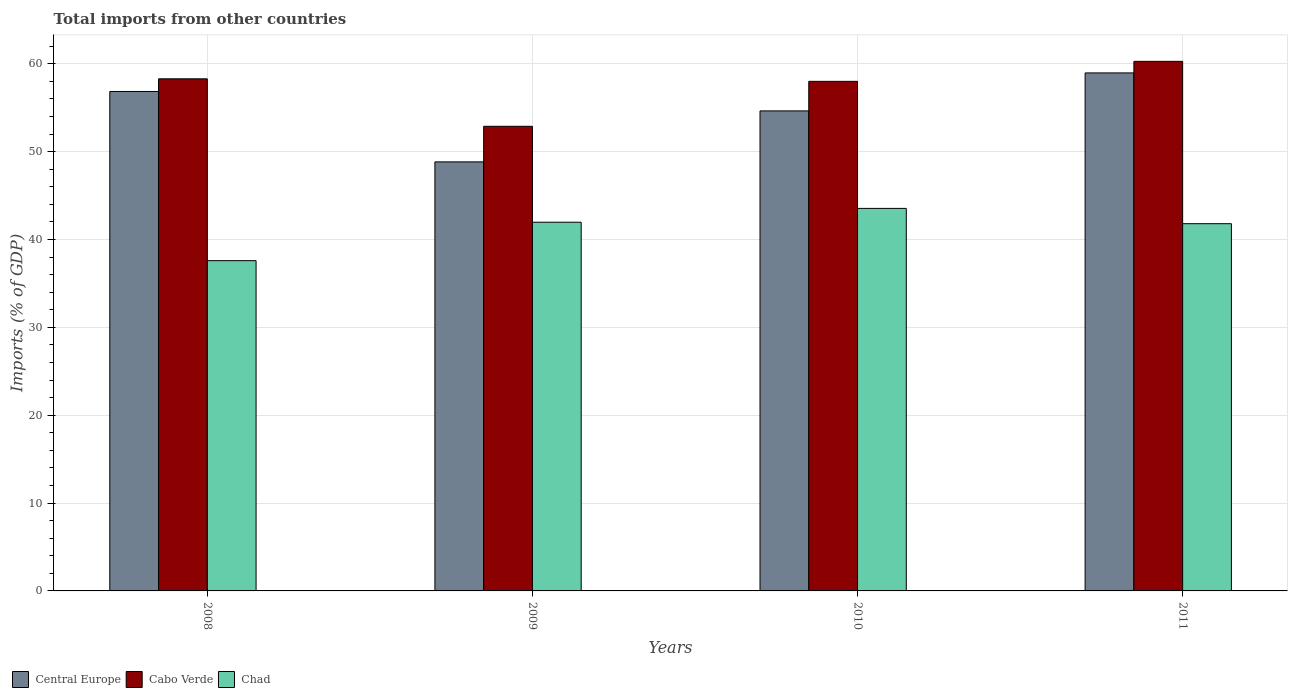Are the number of bars per tick equal to the number of legend labels?
Provide a succinct answer. Yes. Are the number of bars on each tick of the X-axis equal?
Give a very brief answer. Yes. How many bars are there on the 1st tick from the left?
Offer a terse response. 3. What is the total imports in Central Europe in 2008?
Keep it short and to the point. 56.85. Across all years, what is the maximum total imports in Cabo Verde?
Offer a very short reply. 60.28. Across all years, what is the minimum total imports in Central Europe?
Your answer should be compact. 48.84. In which year was the total imports in Central Europe maximum?
Your response must be concise. 2011. What is the total total imports in Chad in the graph?
Provide a short and direct response. 164.92. What is the difference between the total imports in Central Europe in 2009 and that in 2011?
Provide a short and direct response. -10.13. What is the difference between the total imports in Cabo Verde in 2008 and the total imports in Central Europe in 2009?
Your answer should be compact. 9.46. What is the average total imports in Central Europe per year?
Give a very brief answer. 54.83. In the year 2008, what is the difference between the total imports in Cabo Verde and total imports in Central Europe?
Offer a very short reply. 1.44. What is the ratio of the total imports in Central Europe in 2009 to that in 2011?
Keep it short and to the point. 0.83. Is the difference between the total imports in Cabo Verde in 2008 and 2009 greater than the difference between the total imports in Central Europe in 2008 and 2009?
Offer a terse response. No. What is the difference between the highest and the second highest total imports in Chad?
Provide a short and direct response. 1.57. What is the difference between the highest and the lowest total imports in Chad?
Your response must be concise. 5.95. Is the sum of the total imports in Chad in 2008 and 2011 greater than the maximum total imports in Cabo Verde across all years?
Provide a succinct answer. Yes. What does the 1st bar from the left in 2010 represents?
Your answer should be compact. Central Europe. What does the 1st bar from the right in 2009 represents?
Offer a terse response. Chad. Are the values on the major ticks of Y-axis written in scientific E-notation?
Offer a very short reply. No. Does the graph contain any zero values?
Your answer should be compact. No. How many legend labels are there?
Ensure brevity in your answer.  3. What is the title of the graph?
Give a very brief answer. Total imports from other countries. What is the label or title of the Y-axis?
Ensure brevity in your answer.  Imports (% of GDP). What is the Imports (% of GDP) of Central Europe in 2008?
Give a very brief answer. 56.85. What is the Imports (% of GDP) in Cabo Verde in 2008?
Make the answer very short. 58.3. What is the Imports (% of GDP) of Chad in 2008?
Offer a terse response. 37.6. What is the Imports (% of GDP) in Central Europe in 2009?
Provide a short and direct response. 48.84. What is the Imports (% of GDP) of Cabo Verde in 2009?
Provide a short and direct response. 52.89. What is the Imports (% of GDP) of Chad in 2009?
Keep it short and to the point. 41.97. What is the Imports (% of GDP) in Central Europe in 2010?
Your answer should be compact. 54.64. What is the Imports (% of GDP) of Cabo Verde in 2010?
Provide a succinct answer. 58.01. What is the Imports (% of GDP) in Chad in 2010?
Offer a very short reply. 43.55. What is the Imports (% of GDP) in Central Europe in 2011?
Your response must be concise. 58.97. What is the Imports (% of GDP) in Cabo Verde in 2011?
Offer a terse response. 60.28. What is the Imports (% of GDP) in Chad in 2011?
Offer a very short reply. 41.8. Across all years, what is the maximum Imports (% of GDP) of Central Europe?
Provide a short and direct response. 58.97. Across all years, what is the maximum Imports (% of GDP) in Cabo Verde?
Offer a terse response. 60.28. Across all years, what is the maximum Imports (% of GDP) of Chad?
Your response must be concise. 43.55. Across all years, what is the minimum Imports (% of GDP) in Central Europe?
Your answer should be very brief. 48.84. Across all years, what is the minimum Imports (% of GDP) of Cabo Verde?
Your response must be concise. 52.89. Across all years, what is the minimum Imports (% of GDP) in Chad?
Offer a terse response. 37.6. What is the total Imports (% of GDP) in Central Europe in the graph?
Make the answer very short. 219.3. What is the total Imports (% of GDP) in Cabo Verde in the graph?
Offer a terse response. 229.48. What is the total Imports (% of GDP) of Chad in the graph?
Your response must be concise. 164.92. What is the difference between the Imports (% of GDP) in Central Europe in 2008 and that in 2009?
Provide a succinct answer. 8.01. What is the difference between the Imports (% of GDP) of Cabo Verde in 2008 and that in 2009?
Offer a terse response. 5.4. What is the difference between the Imports (% of GDP) in Chad in 2008 and that in 2009?
Provide a succinct answer. -4.38. What is the difference between the Imports (% of GDP) of Central Europe in 2008 and that in 2010?
Make the answer very short. 2.21. What is the difference between the Imports (% of GDP) in Cabo Verde in 2008 and that in 2010?
Your response must be concise. 0.29. What is the difference between the Imports (% of GDP) in Chad in 2008 and that in 2010?
Ensure brevity in your answer.  -5.95. What is the difference between the Imports (% of GDP) of Central Europe in 2008 and that in 2011?
Offer a terse response. -2.11. What is the difference between the Imports (% of GDP) in Cabo Verde in 2008 and that in 2011?
Provide a short and direct response. -1.99. What is the difference between the Imports (% of GDP) of Chad in 2008 and that in 2011?
Provide a succinct answer. -4.21. What is the difference between the Imports (% of GDP) of Central Europe in 2009 and that in 2010?
Your response must be concise. -5.8. What is the difference between the Imports (% of GDP) in Cabo Verde in 2009 and that in 2010?
Offer a terse response. -5.12. What is the difference between the Imports (% of GDP) in Chad in 2009 and that in 2010?
Your response must be concise. -1.57. What is the difference between the Imports (% of GDP) of Central Europe in 2009 and that in 2011?
Provide a succinct answer. -10.13. What is the difference between the Imports (% of GDP) in Cabo Verde in 2009 and that in 2011?
Give a very brief answer. -7.39. What is the difference between the Imports (% of GDP) of Chad in 2009 and that in 2011?
Make the answer very short. 0.17. What is the difference between the Imports (% of GDP) of Central Europe in 2010 and that in 2011?
Offer a terse response. -4.32. What is the difference between the Imports (% of GDP) of Cabo Verde in 2010 and that in 2011?
Offer a terse response. -2.28. What is the difference between the Imports (% of GDP) of Chad in 2010 and that in 2011?
Offer a very short reply. 1.74. What is the difference between the Imports (% of GDP) in Central Europe in 2008 and the Imports (% of GDP) in Cabo Verde in 2009?
Your answer should be compact. 3.96. What is the difference between the Imports (% of GDP) in Central Europe in 2008 and the Imports (% of GDP) in Chad in 2009?
Provide a succinct answer. 14.88. What is the difference between the Imports (% of GDP) in Cabo Verde in 2008 and the Imports (% of GDP) in Chad in 2009?
Offer a terse response. 16.32. What is the difference between the Imports (% of GDP) of Central Europe in 2008 and the Imports (% of GDP) of Cabo Verde in 2010?
Provide a succinct answer. -1.15. What is the difference between the Imports (% of GDP) in Central Europe in 2008 and the Imports (% of GDP) in Chad in 2010?
Your answer should be compact. 13.31. What is the difference between the Imports (% of GDP) of Cabo Verde in 2008 and the Imports (% of GDP) of Chad in 2010?
Give a very brief answer. 14.75. What is the difference between the Imports (% of GDP) of Central Europe in 2008 and the Imports (% of GDP) of Cabo Verde in 2011?
Your response must be concise. -3.43. What is the difference between the Imports (% of GDP) of Central Europe in 2008 and the Imports (% of GDP) of Chad in 2011?
Your answer should be very brief. 15.05. What is the difference between the Imports (% of GDP) in Cabo Verde in 2008 and the Imports (% of GDP) in Chad in 2011?
Your answer should be compact. 16.49. What is the difference between the Imports (% of GDP) of Central Europe in 2009 and the Imports (% of GDP) of Cabo Verde in 2010?
Provide a short and direct response. -9.17. What is the difference between the Imports (% of GDP) in Central Europe in 2009 and the Imports (% of GDP) in Chad in 2010?
Keep it short and to the point. 5.29. What is the difference between the Imports (% of GDP) in Cabo Verde in 2009 and the Imports (% of GDP) in Chad in 2010?
Keep it short and to the point. 9.35. What is the difference between the Imports (% of GDP) of Central Europe in 2009 and the Imports (% of GDP) of Cabo Verde in 2011?
Ensure brevity in your answer.  -11.44. What is the difference between the Imports (% of GDP) in Central Europe in 2009 and the Imports (% of GDP) in Chad in 2011?
Provide a short and direct response. 7.04. What is the difference between the Imports (% of GDP) in Cabo Verde in 2009 and the Imports (% of GDP) in Chad in 2011?
Make the answer very short. 11.09. What is the difference between the Imports (% of GDP) in Central Europe in 2010 and the Imports (% of GDP) in Cabo Verde in 2011?
Your answer should be very brief. -5.64. What is the difference between the Imports (% of GDP) in Central Europe in 2010 and the Imports (% of GDP) in Chad in 2011?
Provide a short and direct response. 12.84. What is the difference between the Imports (% of GDP) in Cabo Verde in 2010 and the Imports (% of GDP) in Chad in 2011?
Offer a very short reply. 16.2. What is the average Imports (% of GDP) in Central Europe per year?
Your answer should be very brief. 54.83. What is the average Imports (% of GDP) in Cabo Verde per year?
Provide a succinct answer. 57.37. What is the average Imports (% of GDP) in Chad per year?
Provide a short and direct response. 41.23. In the year 2008, what is the difference between the Imports (% of GDP) of Central Europe and Imports (% of GDP) of Cabo Verde?
Ensure brevity in your answer.  -1.44. In the year 2008, what is the difference between the Imports (% of GDP) in Central Europe and Imports (% of GDP) in Chad?
Keep it short and to the point. 19.26. In the year 2008, what is the difference between the Imports (% of GDP) in Cabo Verde and Imports (% of GDP) in Chad?
Your answer should be compact. 20.7. In the year 2009, what is the difference between the Imports (% of GDP) of Central Europe and Imports (% of GDP) of Cabo Verde?
Your response must be concise. -4.05. In the year 2009, what is the difference between the Imports (% of GDP) of Central Europe and Imports (% of GDP) of Chad?
Keep it short and to the point. 6.87. In the year 2009, what is the difference between the Imports (% of GDP) of Cabo Verde and Imports (% of GDP) of Chad?
Give a very brief answer. 10.92. In the year 2010, what is the difference between the Imports (% of GDP) in Central Europe and Imports (% of GDP) in Cabo Verde?
Ensure brevity in your answer.  -3.36. In the year 2010, what is the difference between the Imports (% of GDP) of Central Europe and Imports (% of GDP) of Chad?
Make the answer very short. 11.1. In the year 2010, what is the difference between the Imports (% of GDP) in Cabo Verde and Imports (% of GDP) in Chad?
Offer a very short reply. 14.46. In the year 2011, what is the difference between the Imports (% of GDP) of Central Europe and Imports (% of GDP) of Cabo Verde?
Offer a very short reply. -1.32. In the year 2011, what is the difference between the Imports (% of GDP) of Central Europe and Imports (% of GDP) of Chad?
Provide a succinct answer. 17.16. In the year 2011, what is the difference between the Imports (% of GDP) in Cabo Verde and Imports (% of GDP) in Chad?
Provide a short and direct response. 18.48. What is the ratio of the Imports (% of GDP) of Central Europe in 2008 to that in 2009?
Keep it short and to the point. 1.16. What is the ratio of the Imports (% of GDP) of Cabo Verde in 2008 to that in 2009?
Make the answer very short. 1.1. What is the ratio of the Imports (% of GDP) in Chad in 2008 to that in 2009?
Your answer should be very brief. 0.9. What is the ratio of the Imports (% of GDP) of Central Europe in 2008 to that in 2010?
Provide a short and direct response. 1.04. What is the ratio of the Imports (% of GDP) in Cabo Verde in 2008 to that in 2010?
Your answer should be very brief. 1. What is the ratio of the Imports (% of GDP) of Chad in 2008 to that in 2010?
Offer a very short reply. 0.86. What is the ratio of the Imports (% of GDP) in Central Europe in 2008 to that in 2011?
Your response must be concise. 0.96. What is the ratio of the Imports (% of GDP) of Chad in 2008 to that in 2011?
Your response must be concise. 0.9. What is the ratio of the Imports (% of GDP) of Central Europe in 2009 to that in 2010?
Your answer should be compact. 0.89. What is the ratio of the Imports (% of GDP) of Cabo Verde in 2009 to that in 2010?
Provide a short and direct response. 0.91. What is the ratio of the Imports (% of GDP) in Chad in 2009 to that in 2010?
Make the answer very short. 0.96. What is the ratio of the Imports (% of GDP) in Central Europe in 2009 to that in 2011?
Offer a terse response. 0.83. What is the ratio of the Imports (% of GDP) in Cabo Verde in 2009 to that in 2011?
Your answer should be very brief. 0.88. What is the ratio of the Imports (% of GDP) in Chad in 2009 to that in 2011?
Provide a succinct answer. 1. What is the ratio of the Imports (% of GDP) in Central Europe in 2010 to that in 2011?
Give a very brief answer. 0.93. What is the ratio of the Imports (% of GDP) of Cabo Verde in 2010 to that in 2011?
Provide a succinct answer. 0.96. What is the ratio of the Imports (% of GDP) of Chad in 2010 to that in 2011?
Make the answer very short. 1.04. What is the difference between the highest and the second highest Imports (% of GDP) in Central Europe?
Your answer should be compact. 2.11. What is the difference between the highest and the second highest Imports (% of GDP) in Cabo Verde?
Your answer should be compact. 1.99. What is the difference between the highest and the second highest Imports (% of GDP) in Chad?
Your answer should be very brief. 1.57. What is the difference between the highest and the lowest Imports (% of GDP) in Central Europe?
Ensure brevity in your answer.  10.13. What is the difference between the highest and the lowest Imports (% of GDP) in Cabo Verde?
Ensure brevity in your answer.  7.39. What is the difference between the highest and the lowest Imports (% of GDP) in Chad?
Offer a very short reply. 5.95. 